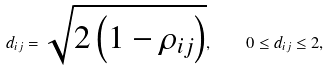<formula> <loc_0><loc_0><loc_500><loc_500>d _ { i j } = \sqrt { 2 \left ( 1 - \rho _ { i j } \right ) } , \quad 0 \leq d _ { i j } \leq 2 ,</formula> 